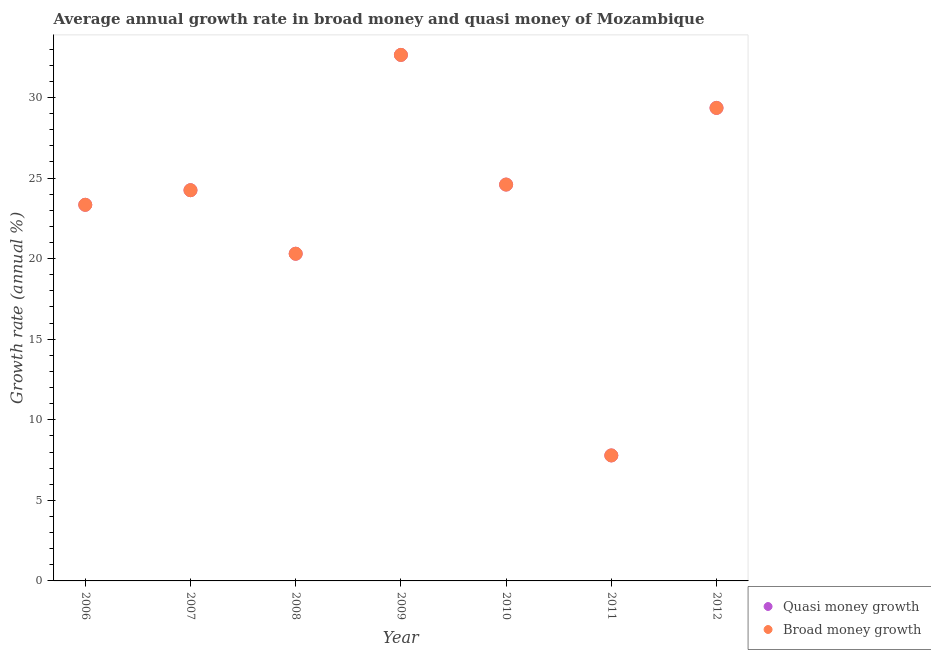Is the number of dotlines equal to the number of legend labels?
Your response must be concise. Yes. What is the annual growth rate in broad money in 2006?
Ensure brevity in your answer.  23.34. Across all years, what is the maximum annual growth rate in broad money?
Your response must be concise. 32.64. Across all years, what is the minimum annual growth rate in quasi money?
Provide a succinct answer. 7.79. What is the total annual growth rate in quasi money in the graph?
Your answer should be compact. 162.28. What is the difference between the annual growth rate in quasi money in 2006 and that in 2009?
Give a very brief answer. -9.3. What is the difference between the annual growth rate in broad money in 2011 and the annual growth rate in quasi money in 2009?
Give a very brief answer. -24.86. What is the average annual growth rate in broad money per year?
Your answer should be very brief. 23.18. In how many years, is the annual growth rate in broad money greater than 9 %?
Make the answer very short. 6. What is the ratio of the annual growth rate in broad money in 2006 to that in 2008?
Your response must be concise. 1.15. Is the annual growth rate in broad money in 2008 less than that in 2010?
Offer a terse response. Yes. Is the difference between the annual growth rate in broad money in 2009 and 2012 greater than the difference between the annual growth rate in quasi money in 2009 and 2012?
Your answer should be very brief. No. What is the difference between the highest and the second highest annual growth rate in broad money?
Offer a very short reply. 3.29. What is the difference between the highest and the lowest annual growth rate in broad money?
Your answer should be compact. 24.86. Is the sum of the annual growth rate in quasi money in 2007 and 2012 greater than the maximum annual growth rate in broad money across all years?
Provide a short and direct response. Yes. Is the annual growth rate in quasi money strictly greater than the annual growth rate in broad money over the years?
Offer a very short reply. No. How many dotlines are there?
Provide a succinct answer. 2. How many years are there in the graph?
Your response must be concise. 7. Does the graph contain grids?
Keep it short and to the point. No. Where does the legend appear in the graph?
Give a very brief answer. Bottom right. How many legend labels are there?
Your answer should be compact. 2. How are the legend labels stacked?
Your answer should be compact. Vertical. What is the title of the graph?
Your answer should be compact. Average annual growth rate in broad money and quasi money of Mozambique. Does "GDP at market prices" appear as one of the legend labels in the graph?
Provide a short and direct response. No. What is the label or title of the Y-axis?
Your response must be concise. Growth rate (annual %). What is the Growth rate (annual %) in Quasi money growth in 2006?
Your response must be concise. 23.34. What is the Growth rate (annual %) of Broad money growth in 2006?
Your answer should be very brief. 23.34. What is the Growth rate (annual %) of Quasi money growth in 2007?
Your answer should be very brief. 24.25. What is the Growth rate (annual %) in Broad money growth in 2007?
Provide a succinct answer. 24.25. What is the Growth rate (annual %) in Quasi money growth in 2008?
Your answer should be very brief. 20.3. What is the Growth rate (annual %) of Broad money growth in 2008?
Offer a very short reply. 20.3. What is the Growth rate (annual %) in Quasi money growth in 2009?
Your answer should be very brief. 32.64. What is the Growth rate (annual %) in Broad money growth in 2009?
Ensure brevity in your answer.  32.64. What is the Growth rate (annual %) in Quasi money growth in 2010?
Ensure brevity in your answer.  24.6. What is the Growth rate (annual %) in Broad money growth in 2010?
Give a very brief answer. 24.6. What is the Growth rate (annual %) of Quasi money growth in 2011?
Ensure brevity in your answer.  7.79. What is the Growth rate (annual %) in Broad money growth in 2011?
Provide a short and direct response. 7.79. What is the Growth rate (annual %) of Quasi money growth in 2012?
Your answer should be compact. 29.35. What is the Growth rate (annual %) in Broad money growth in 2012?
Make the answer very short. 29.35. Across all years, what is the maximum Growth rate (annual %) of Quasi money growth?
Provide a short and direct response. 32.64. Across all years, what is the maximum Growth rate (annual %) in Broad money growth?
Offer a very short reply. 32.64. Across all years, what is the minimum Growth rate (annual %) of Quasi money growth?
Offer a terse response. 7.79. Across all years, what is the minimum Growth rate (annual %) in Broad money growth?
Provide a short and direct response. 7.79. What is the total Growth rate (annual %) in Quasi money growth in the graph?
Your answer should be very brief. 162.28. What is the total Growth rate (annual %) in Broad money growth in the graph?
Keep it short and to the point. 162.28. What is the difference between the Growth rate (annual %) in Quasi money growth in 2006 and that in 2007?
Ensure brevity in your answer.  -0.91. What is the difference between the Growth rate (annual %) of Broad money growth in 2006 and that in 2007?
Your response must be concise. -0.91. What is the difference between the Growth rate (annual %) of Quasi money growth in 2006 and that in 2008?
Give a very brief answer. 3.04. What is the difference between the Growth rate (annual %) in Broad money growth in 2006 and that in 2008?
Offer a very short reply. 3.04. What is the difference between the Growth rate (annual %) in Quasi money growth in 2006 and that in 2009?
Offer a terse response. -9.3. What is the difference between the Growth rate (annual %) of Broad money growth in 2006 and that in 2009?
Give a very brief answer. -9.3. What is the difference between the Growth rate (annual %) in Quasi money growth in 2006 and that in 2010?
Provide a succinct answer. -1.26. What is the difference between the Growth rate (annual %) of Broad money growth in 2006 and that in 2010?
Offer a terse response. -1.26. What is the difference between the Growth rate (annual %) of Quasi money growth in 2006 and that in 2011?
Offer a very short reply. 15.55. What is the difference between the Growth rate (annual %) of Broad money growth in 2006 and that in 2011?
Provide a short and direct response. 15.55. What is the difference between the Growth rate (annual %) in Quasi money growth in 2006 and that in 2012?
Give a very brief answer. -6.01. What is the difference between the Growth rate (annual %) of Broad money growth in 2006 and that in 2012?
Offer a terse response. -6.01. What is the difference between the Growth rate (annual %) in Quasi money growth in 2007 and that in 2008?
Make the answer very short. 3.94. What is the difference between the Growth rate (annual %) of Broad money growth in 2007 and that in 2008?
Offer a terse response. 3.94. What is the difference between the Growth rate (annual %) in Quasi money growth in 2007 and that in 2009?
Your response must be concise. -8.4. What is the difference between the Growth rate (annual %) of Broad money growth in 2007 and that in 2009?
Provide a succinct answer. -8.4. What is the difference between the Growth rate (annual %) of Quasi money growth in 2007 and that in 2010?
Give a very brief answer. -0.35. What is the difference between the Growth rate (annual %) of Broad money growth in 2007 and that in 2010?
Ensure brevity in your answer.  -0.35. What is the difference between the Growth rate (annual %) of Quasi money growth in 2007 and that in 2011?
Your answer should be very brief. 16.46. What is the difference between the Growth rate (annual %) in Broad money growth in 2007 and that in 2011?
Give a very brief answer. 16.46. What is the difference between the Growth rate (annual %) of Quasi money growth in 2007 and that in 2012?
Give a very brief answer. -5.11. What is the difference between the Growth rate (annual %) in Broad money growth in 2007 and that in 2012?
Make the answer very short. -5.11. What is the difference between the Growth rate (annual %) of Quasi money growth in 2008 and that in 2009?
Ensure brevity in your answer.  -12.34. What is the difference between the Growth rate (annual %) of Broad money growth in 2008 and that in 2009?
Provide a succinct answer. -12.34. What is the difference between the Growth rate (annual %) of Quasi money growth in 2008 and that in 2010?
Your response must be concise. -4.29. What is the difference between the Growth rate (annual %) in Broad money growth in 2008 and that in 2010?
Offer a very short reply. -4.29. What is the difference between the Growth rate (annual %) in Quasi money growth in 2008 and that in 2011?
Provide a succinct answer. 12.52. What is the difference between the Growth rate (annual %) in Broad money growth in 2008 and that in 2011?
Your answer should be very brief. 12.52. What is the difference between the Growth rate (annual %) of Quasi money growth in 2008 and that in 2012?
Keep it short and to the point. -9.05. What is the difference between the Growth rate (annual %) of Broad money growth in 2008 and that in 2012?
Make the answer very short. -9.05. What is the difference between the Growth rate (annual %) in Quasi money growth in 2009 and that in 2010?
Your answer should be compact. 8.05. What is the difference between the Growth rate (annual %) of Broad money growth in 2009 and that in 2010?
Your answer should be very brief. 8.05. What is the difference between the Growth rate (annual %) of Quasi money growth in 2009 and that in 2011?
Offer a very short reply. 24.86. What is the difference between the Growth rate (annual %) in Broad money growth in 2009 and that in 2011?
Your answer should be compact. 24.86. What is the difference between the Growth rate (annual %) in Quasi money growth in 2009 and that in 2012?
Ensure brevity in your answer.  3.29. What is the difference between the Growth rate (annual %) in Broad money growth in 2009 and that in 2012?
Offer a terse response. 3.29. What is the difference between the Growth rate (annual %) of Quasi money growth in 2010 and that in 2011?
Your response must be concise. 16.81. What is the difference between the Growth rate (annual %) in Broad money growth in 2010 and that in 2011?
Offer a terse response. 16.81. What is the difference between the Growth rate (annual %) of Quasi money growth in 2010 and that in 2012?
Provide a succinct answer. -4.76. What is the difference between the Growth rate (annual %) in Broad money growth in 2010 and that in 2012?
Your answer should be very brief. -4.76. What is the difference between the Growth rate (annual %) in Quasi money growth in 2011 and that in 2012?
Offer a very short reply. -21.57. What is the difference between the Growth rate (annual %) in Broad money growth in 2011 and that in 2012?
Provide a succinct answer. -21.57. What is the difference between the Growth rate (annual %) of Quasi money growth in 2006 and the Growth rate (annual %) of Broad money growth in 2007?
Keep it short and to the point. -0.91. What is the difference between the Growth rate (annual %) in Quasi money growth in 2006 and the Growth rate (annual %) in Broad money growth in 2008?
Provide a short and direct response. 3.04. What is the difference between the Growth rate (annual %) of Quasi money growth in 2006 and the Growth rate (annual %) of Broad money growth in 2009?
Offer a terse response. -9.3. What is the difference between the Growth rate (annual %) of Quasi money growth in 2006 and the Growth rate (annual %) of Broad money growth in 2010?
Provide a short and direct response. -1.26. What is the difference between the Growth rate (annual %) of Quasi money growth in 2006 and the Growth rate (annual %) of Broad money growth in 2011?
Offer a very short reply. 15.55. What is the difference between the Growth rate (annual %) in Quasi money growth in 2006 and the Growth rate (annual %) in Broad money growth in 2012?
Provide a succinct answer. -6.01. What is the difference between the Growth rate (annual %) of Quasi money growth in 2007 and the Growth rate (annual %) of Broad money growth in 2008?
Your answer should be compact. 3.94. What is the difference between the Growth rate (annual %) in Quasi money growth in 2007 and the Growth rate (annual %) in Broad money growth in 2009?
Offer a terse response. -8.4. What is the difference between the Growth rate (annual %) of Quasi money growth in 2007 and the Growth rate (annual %) of Broad money growth in 2010?
Offer a very short reply. -0.35. What is the difference between the Growth rate (annual %) in Quasi money growth in 2007 and the Growth rate (annual %) in Broad money growth in 2011?
Provide a succinct answer. 16.46. What is the difference between the Growth rate (annual %) in Quasi money growth in 2007 and the Growth rate (annual %) in Broad money growth in 2012?
Keep it short and to the point. -5.11. What is the difference between the Growth rate (annual %) in Quasi money growth in 2008 and the Growth rate (annual %) in Broad money growth in 2009?
Your response must be concise. -12.34. What is the difference between the Growth rate (annual %) in Quasi money growth in 2008 and the Growth rate (annual %) in Broad money growth in 2010?
Make the answer very short. -4.29. What is the difference between the Growth rate (annual %) in Quasi money growth in 2008 and the Growth rate (annual %) in Broad money growth in 2011?
Offer a very short reply. 12.52. What is the difference between the Growth rate (annual %) of Quasi money growth in 2008 and the Growth rate (annual %) of Broad money growth in 2012?
Offer a very short reply. -9.05. What is the difference between the Growth rate (annual %) in Quasi money growth in 2009 and the Growth rate (annual %) in Broad money growth in 2010?
Provide a succinct answer. 8.05. What is the difference between the Growth rate (annual %) of Quasi money growth in 2009 and the Growth rate (annual %) of Broad money growth in 2011?
Keep it short and to the point. 24.86. What is the difference between the Growth rate (annual %) in Quasi money growth in 2009 and the Growth rate (annual %) in Broad money growth in 2012?
Your answer should be compact. 3.29. What is the difference between the Growth rate (annual %) of Quasi money growth in 2010 and the Growth rate (annual %) of Broad money growth in 2011?
Ensure brevity in your answer.  16.81. What is the difference between the Growth rate (annual %) in Quasi money growth in 2010 and the Growth rate (annual %) in Broad money growth in 2012?
Keep it short and to the point. -4.76. What is the difference between the Growth rate (annual %) of Quasi money growth in 2011 and the Growth rate (annual %) of Broad money growth in 2012?
Offer a very short reply. -21.57. What is the average Growth rate (annual %) of Quasi money growth per year?
Ensure brevity in your answer.  23.18. What is the average Growth rate (annual %) in Broad money growth per year?
Provide a short and direct response. 23.18. In the year 2006, what is the difference between the Growth rate (annual %) in Quasi money growth and Growth rate (annual %) in Broad money growth?
Keep it short and to the point. 0. In the year 2007, what is the difference between the Growth rate (annual %) in Quasi money growth and Growth rate (annual %) in Broad money growth?
Make the answer very short. 0. In the year 2008, what is the difference between the Growth rate (annual %) in Quasi money growth and Growth rate (annual %) in Broad money growth?
Your answer should be very brief. 0. What is the ratio of the Growth rate (annual %) of Quasi money growth in 2006 to that in 2007?
Give a very brief answer. 0.96. What is the ratio of the Growth rate (annual %) of Broad money growth in 2006 to that in 2007?
Offer a terse response. 0.96. What is the ratio of the Growth rate (annual %) of Quasi money growth in 2006 to that in 2008?
Your response must be concise. 1.15. What is the ratio of the Growth rate (annual %) in Broad money growth in 2006 to that in 2008?
Your answer should be very brief. 1.15. What is the ratio of the Growth rate (annual %) of Quasi money growth in 2006 to that in 2009?
Your answer should be very brief. 0.71. What is the ratio of the Growth rate (annual %) in Broad money growth in 2006 to that in 2009?
Your answer should be compact. 0.71. What is the ratio of the Growth rate (annual %) of Quasi money growth in 2006 to that in 2010?
Your answer should be compact. 0.95. What is the ratio of the Growth rate (annual %) in Broad money growth in 2006 to that in 2010?
Provide a succinct answer. 0.95. What is the ratio of the Growth rate (annual %) of Quasi money growth in 2006 to that in 2011?
Offer a terse response. 3. What is the ratio of the Growth rate (annual %) in Broad money growth in 2006 to that in 2011?
Your response must be concise. 3. What is the ratio of the Growth rate (annual %) of Quasi money growth in 2006 to that in 2012?
Make the answer very short. 0.8. What is the ratio of the Growth rate (annual %) in Broad money growth in 2006 to that in 2012?
Offer a very short reply. 0.8. What is the ratio of the Growth rate (annual %) in Quasi money growth in 2007 to that in 2008?
Make the answer very short. 1.19. What is the ratio of the Growth rate (annual %) of Broad money growth in 2007 to that in 2008?
Your answer should be very brief. 1.19. What is the ratio of the Growth rate (annual %) of Quasi money growth in 2007 to that in 2009?
Offer a terse response. 0.74. What is the ratio of the Growth rate (annual %) in Broad money growth in 2007 to that in 2009?
Provide a succinct answer. 0.74. What is the ratio of the Growth rate (annual %) of Quasi money growth in 2007 to that in 2010?
Your answer should be very brief. 0.99. What is the ratio of the Growth rate (annual %) in Broad money growth in 2007 to that in 2010?
Provide a succinct answer. 0.99. What is the ratio of the Growth rate (annual %) of Quasi money growth in 2007 to that in 2011?
Your answer should be very brief. 3.11. What is the ratio of the Growth rate (annual %) in Broad money growth in 2007 to that in 2011?
Give a very brief answer. 3.11. What is the ratio of the Growth rate (annual %) of Quasi money growth in 2007 to that in 2012?
Make the answer very short. 0.83. What is the ratio of the Growth rate (annual %) of Broad money growth in 2007 to that in 2012?
Give a very brief answer. 0.83. What is the ratio of the Growth rate (annual %) of Quasi money growth in 2008 to that in 2009?
Your response must be concise. 0.62. What is the ratio of the Growth rate (annual %) in Broad money growth in 2008 to that in 2009?
Your answer should be compact. 0.62. What is the ratio of the Growth rate (annual %) of Quasi money growth in 2008 to that in 2010?
Keep it short and to the point. 0.83. What is the ratio of the Growth rate (annual %) in Broad money growth in 2008 to that in 2010?
Offer a very short reply. 0.83. What is the ratio of the Growth rate (annual %) of Quasi money growth in 2008 to that in 2011?
Give a very brief answer. 2.61. What is the ratio of the Growth rate (annual %) in Broad money growth in 2008 to that in 2011?
Provide a short and direct response. 2.61. What is the ratio of the Growth rate (annual %) of Quasi money growth in 2008 to that in 2012?
Keep it short and to the point. 0.69. What is the ratio of the Growth rate (annual %) of Broad money growth in 2008 to that in 2012?
Your response must be concise. 0.69. What is the ratio of the Growth rate (annual %) in Quasi money growth in 2009 to that in 2010?
Provide a short and direct response. 1.33. What is the ratio of the Growth rate (annual %) in Broad money growth in 2009 to that in 2010?
Keep it short and to the point. 1.33. What is the ratio of the Growth rate (annual %) in Quasi money growth in 2009 to that in 2011?
Make the answer very short. 4.19. What is the ratio of the Growth rate (annual %) in Broad money growth in 2009 to that in 2011?
Keep it short and to the point. 4.19. What is the ratio of the Growth rate (annual %) of Quasi money growth in 2009 to that in 2012?
Offer a very short reply. 1.11. What is the ratio of the Growth rate (annual %) in Broad money growth in 2009 to that in 2012?
Offer a very short reply. 1.11. What is the ratio of the Growth rate (annual %) of Quasi money growth in 2010 to that in 2011?
Your response must be concise. 3.16. What is the ratio of the Growth rate (annual %) of Broad money growth in 2010 to that in 2011?
Offer a terse response. 3.16. What is the ratio of the Growth rate (annual %) of Quasi money growth in 2010 to that in 2012?
Provide a short and direct response. 0.84. What is the ratio of the Growth rate (annual %) of Broad money growth in 2010 to that in 2012?
Provide a succinct answer. 0.84. What is the ratio of the Growth rate (annual %) in Quasi money growth in 2011 to that in 2012?
Make the answer very short. 0.27. What is the ratio of the Growth rate (annual %) in Broad money growth in 2011 to that in 2012?
Ensure brevity in your answer.  0.27. What is the difference between the highest and the second highest Growth rate (annual %) in Quasi money growth?
Ensure brevity in your answer.  3.29. What is the difference between the highest and the second highest Growth rate (annual %) in Broad money growth?
Your answer should be very brief. 3.29. What is the difference between the highest and the lowest Growth rate (annual %) in Quasi money growth?
Your answer should be compact. 24.86. What is the difference between the highest and the lowest Growth rate (annual %) in Broad money growth?
Offer a terse response. 24.86. 